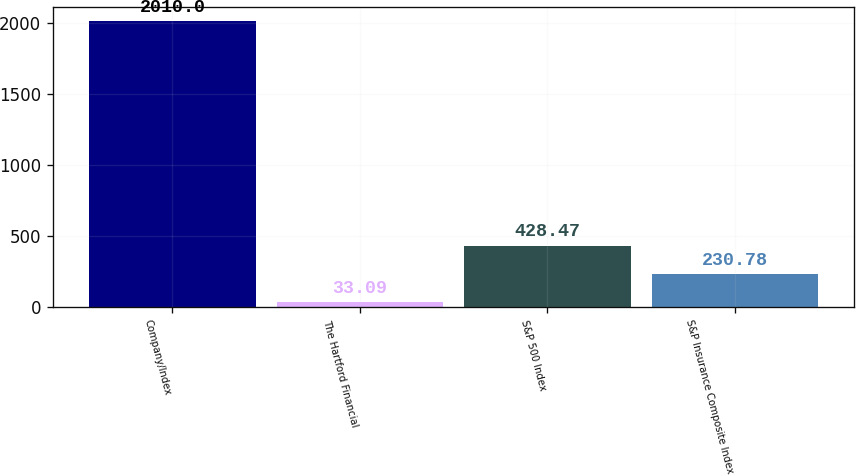<chart> <loc_0><loc_0><loc_500><loc_500><bar_chart><fcel>Company/Index<fcel>The Hartford Financial<fcel>S&P 500 Index<fcel>S&P Insurance Composite Index<nl><fcel>2010<fcel>33.09<fcel>428.47<fcel>230.78<nl></chart> 